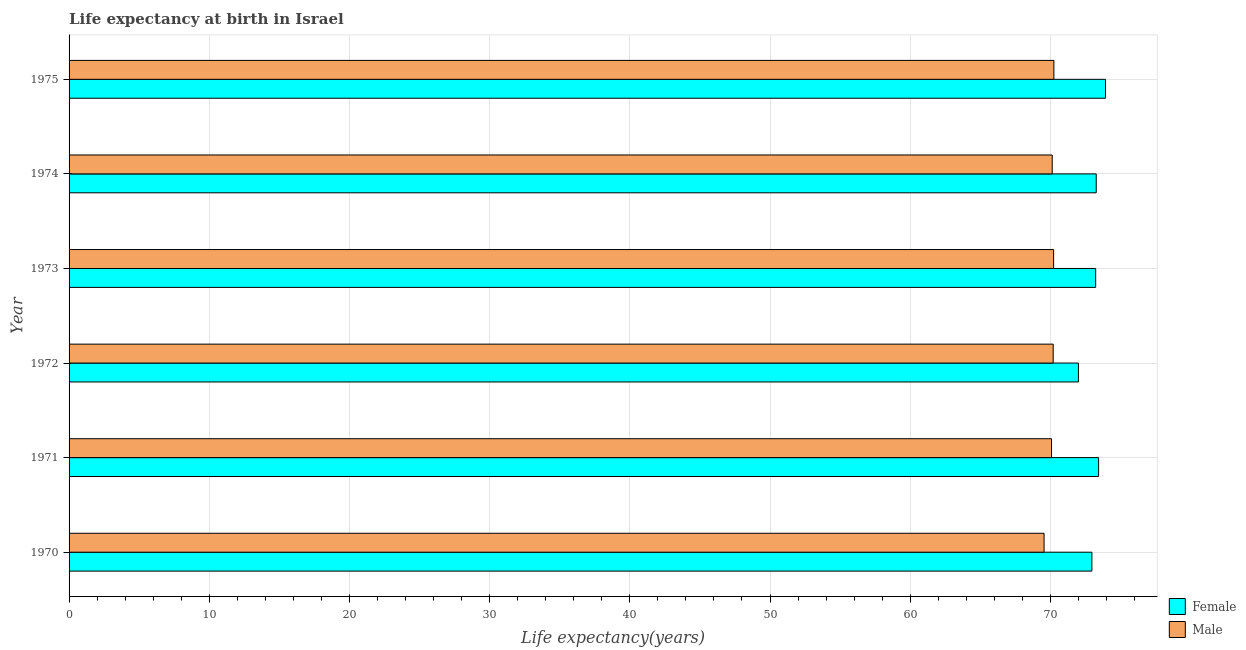How many different coloured bars are there?
Give a very brief answer. 2. Are the number of bars per tick equal to the number of legend labels?
Your answer should be very brief. Yes. Are the number of bars on each tick of the Y-axis equal?
Your response must be concise. Yes. How many bars are there on the 6th tick from the top?
Provide a succinct answer. 2. How many bars are there on the 1st tick from the bottom?
Keep it short and to the point. 2. What is the label of the 3rd group of bars from the top?
Your answer should be compact. 1973. In how many cases, is the number of bars for a given year not equal to the number of legend labels?
Offer a very short reply. 0. What is the life expectancy(male) in 1974?
Your answer should be compact. 70.13. Across all years, what is the maximum life expectancy(male)?
Provide a succinct answer. 70.25. In which year was the life expectancy(male) maximum?
Your answer should be compact. 1975. In which year was the life expectancy(male) minimum?
Your answer should be compact. 1970. What is the total life expectancy(female) in the graph?
Provide a short and direct response. 438.83. What is the difference between the life expectancy(male) in 1970 and that in 1973?
Ensure brevity in your answer.  -0.68. What is the difference between the life expectancy(male) in 1971 and the life expectancy(female) in 1970?
Your response must be concise. -2.88. What is the average life expectancy(male) per year?
Ensure brevity in your answer.  70.07. Is the difference between the life expectancy(male) in 1970 and 1973 greater than the difference between the life expectancy(female) in 1970 and 1973?
Make the answer very short. No. What is the difference between the highest and the second highest life expectancy(female)?
Ensure brevity in your answer.  0.49. What is the difference between the highest and the lowest life expectancy(female)?
Provide a succinct answer. 1.93. What does the 2nd bar from the top in 1972 represents?
Your answer should be compact. Female. What does the 2nd bar from the bottom in 1973 represents?
Make the answer very short. Male. Are all the bars in the graph horizontal?
Your answer should be very brief. Yes. How many years are there in the graph?
Provide a short and direct response. 6. What is the difference between two consecutive major ticks on the X-axis?
Offer a very short reply. 10. Are the values on the major ticks of X-axis written in scientific E-notation?
Offer a terse response. No. Does the graph contain any zero values?
Make the answer very short. No. Does the graph contain grids?
Keep it short and to the point. Yes. Where does the legend appear in the graph?
Ensure brevity in your answer.  Bottom right. How many legend labels are there?
Your answer should be compact. 2. How are the legend labels stacked?
Keep it short and to the point. Vertical. What is the title of the graph?
Provide a succinct answer. Life expectancy at birth in Israel. Does "Health Care" appear as one of the legend labels in the graph?
Give a very brief answer. No. What is the label or title of the X-axis?
Provide a succinct answer. Life expectancy(years). What is the label or title of the Y-axis?
Provide a succinct answer. Year. What is the Life expectancy(years) of Female in 1970?
Your answer should be very brief. 72.96. What is the Life expectancy(years) of Male in 1970?
Provide a succinct answer. 69.55. What is the Life expectancy(years) in Female in 1971?
Make the answer very short. 73.44. What is the Life expectancy(years) in Male in 1971?
Provide a short and direct response. 70.08. What is the Life expectancy(years) of Female in 1972?
Provide a succinct answer. 72. What is the Life expectancy(years) in Male in 1972?
Provide a succinct answer. 70.2. What is the Life expectancy(years) in Female in 1973?
Offer a very short reply. 73.23. What is the Life expectancy(years) in Male in 1973?
Provide a short and direct response. 70.23. What is the Life expectancy(years) of Female in 1974?
Keep it short and to the point. 73.27. What is the Life expectancy(years) of Male in 1974?
Your answer should be compact. 70.13. What is the Life expectancy(years) in Female in 1975?
Make the answer very short. 73.93. What is the Life expectancy(years) in Male in 1975?
Give a very brief answer. 70.25. Across all years, what is the maximum Life expectancy(years) of Female?
Offer a very short reply. 73.93. Across all years, what is the maximum Life expectancy(years) of Male?
Ensure brevity in your answer.  70.25. Across all years, what is the minimum Life expectancy(years) in Male?
Make the answer very short. 69.55. What is the total Life expectancy(years) in Female in the graph?
Provide a succinct answer. 438.83. What is the total Life expectancy(years) in Male in the graph?
Make the answer very short. 420.44. What is the difference between the Life expectancy(years) of Female in 1970 and that in 1971?
Offer a very short reply. -0.48. What is the difference between the Life expectancy(years) in Male in 1970 and that in 1971?
Offer a very short reply. -0.53. What is the difference between the Life expectancy(years) of Male in 1970 and that in 1972?
Make the answer very short. -0.65. What is the difference between the Life expectancy(years) of Female in 1970 and that in 1973?
Your answer should be very brief. -0.27. What is the difference between the Life expectancy(years) in Male in 1970 and that in 1973?
Provide a short and direct response. -0.68. What is the difference between the Life expectancy(years) in Female in 1970 and that in 1974?
Ensure brevity in your answer.  -0.31. What is the difference between the Life expectancy(years) in Male in 1970 and that in 1974?
Offer a terse response. -0.58. What is the difference between the Life expectancy(years) in Female in 1970 and that in 1975?
Give a very brief answer. -0.97. What is the difference between the Life expectancy(years) of Female in 1971 and that in 1972?
Make the answer very short. 1.44. What is the difference between the Life expectancy(years) of Male in 1971 and that in 1972?
Offer a terse response. -0.12. What is the difference between the Life expectancy(years) of Female in 1971 and that in 1973?
Your response must be concise. 0.21. What is the difference between the Life expectancy(years) of Female in 1971 and that in 1974?
Ensure brevity in your answer.  0.17. What is the difference between the Life expectancy(years) of Female in 1971 and that in 1975?
Your response must be concise. -0.49. What is the difference between the Life expectancy(years) in Male in 1971 and that in 1975?
Ensure brevity in your answer.  -0.17. What is the difference between the Life expectancy(years) of Female in 1972 and that in 1973?
Your answer should be very brief. -1.23. What is the difference between the Life expectancy(years) in Male in 1972 and that in 1973?
Your answer should be compact. -0.03. What is the difference between the Life expectancy(years) of Female in 1972 and that in 1974?
Offer a terse response. -1.27. What is the difference between the Life expectancy(years) of Male in 1972 and that in 1974?
Offer a terse response. 0.07. What is the difference between the Life expectancy(years) in Female in 1972 and that in 1975?
Your response must be concise. -1.93. What is the difference between the Life expectancy(years) in Male in 1972 and that in 1975?
Keep it short and to the point. -0.05. What is the difference between the Life expectancy(years) of Female in 1973 and that in 1974?
Offer a very short reply. -0.04. What is the difference between the Life expectancy(years) of Male in 1973 and that in 1974?
Ensure brevity in your answer.  0.1. What is the difference between the Life expectancy(years) in Female in 1973 and that in 1975?
Your response must be concise. -0.7. What is the difference between the Life expectancy(years) in Male in 1973 and that in 1975?
Provide a short and direct response. -0.02. What is the difference between the Life expectancy(years) in Female in 1974 and that in 1975?
Ensure brevity in your answer.  -0.66. What is the difference between the Life expectancy(years) of Male in 1974 and that in 1975?
Your answer should be compact. -0.12. What is the difference between the Life expectancy(years) of Female in 1970 and the Life expectancy(years) of Male in 1971?
Your response must be concise. 2.88. What is the difference between the Life expectancy(years) in Female in 1970 and the Life expectancy(years) in Male in 1972?
Offer a terse response. 2.76. What is the difference between the Life expectancy(years) in Female in 1970 and the Life expectancy(years) in Male in 1973?
Make the answer very short. 2.73. What is the difference between the Life expectancy(years) of Female in 1970 and the Life expectancy(years) of Male in 1974?
Your answer should be compact. 2.83. What is the difference between the Life expectancy(years) of Female in 1970 and the Life expectancy(years) of Male in 1975?
Provide a short and direct response. 2.71. What is the difference between the Life expectancy(years) of Female in 1971 and the Life expectancy(years) of Male in 1972?
Provide a short and direct response. 3.24. What is the difference between the Life expectancy(years) of Female in 1971 and the Life expectancy(years) of Male in 1973?
Your response must be concise. 3.21. What is the difference between the Life expectancy(years) in Female in 1971 and the Life expectancy(years) in Male in 1974?
Your answer should be compact. 3.31. What is the difference between the Life expectancy(years) of Female in 1971 and the Life expectancy(years) of Male in 1975?
Offer a very short reply. 3.19. What is the difference between the Life expectancy(years) in Female in 1972 and the Life expectancy(years) in Male in 1973?
Your answer should be very brief. 1.77. What is the difference between the Life expectancy(years) in Female in 1972 and the Life expectancy(years) in Male in 1974?
Ensure brevity in your answer.  1.87. What is the difference between the Life expectancy(years) in Female in 1972 and the Life expectancy(years) in Male in 1975?
Your response must be concise. 1.75. What is the difference between the Life expectancy(years) of Female in 1973 and the Life expectancy(years) of Male in 1974?
Give a very brief answer. 3.1. What is the difference between the Life expectancy(years) in Female in 1973 and the Life expectancy(years) in Male in 1975?
Ensure brevity in your answer.  2.98. What is the difference between the Life expectancy(years) of Female in 1974 and the Life expectancy(years) of Male in 1975?
Your response must be concise. 3.02. What is the average Life expectancy(years) in Female per year?
Offer a terse response. 73.14. What is the average Life expectancy(years) in Male per year?
Keep it short and to the point. 70.07. In the year 1970, what is the difference between the Life expectancy(years) of Female and Life expectancy(years) of Male?
Give a very brief answer. 3.41. In the year 1971, what is the difference between the Life expectancy(years) of Female and Life expectancy(years) of Male?
Offer a very short reply. 3.36. In the year 1972, what is the difference between the Life expectancy(years) of Female and Life expectancy(years) of Male?
Offer a terse response. 1.8. In the year 1974, what is the difference between the Life expectancy(years) in Female and Life expectancy(years) in Male?
Provide a short and direct response. 3.14. In the year 1975, what is the difference between the Life expectancy(years) of Female and Life expectancy(years) of Male?
Your response must be concise. 3.68. What is the ratio of the Life expectancy(years) of Male in 1970 to that in 1971?
Your response must be concise. 0.99. What is the ratio of the Life expectancy(years) in Female in 1970 to that in 1972?
Offer a terse response. 1.01. What is the ratio of the Life expectancy(years) in Female in 1970 to that in 1973?
Offer a terse response. 1. What is the ratio of the Life expectancy(years) in Male in 1970 to that in 1973?
Ensure brevity in your answer.  0.99. What is the ratio of the Life expectancy(years) of Male in 1970 to that in 1974?
Make the answer very short. 0.99. What is the ratio of the Life expectancy(years) in Female in 1970 to that in 1975?
Make the answer very short. 0.99. What is the ratio of the Life expectancy(years) in Male in 1970 to that in 1975?
Your response must be concise. 0.99. What is the ratio of the Life expectancy(years) of Male in 1971 to that in 1973?
Keep it short and to the point. 1. What is the ratio of the Life expectancy(years) in Male in 1971 to that in 1974?
Provide a short and direct response. 1. What is the ratio of the Life expectancy(years) of Female in 1971 to that in 1975?
Your answer should be compact. 0.99. What is the ratio of the Life expectancy(years) of Male in 1971 to that in 1975?
Ensure brevity in your answer.  1. What is the ratio of the Life expectancy(years) of Female in 1972 to that in 1973?
Offer a terse response. 0.98. What is the ratio of the Life expectancy(years) in Female in 1972 to that in 1974?
Your response must be concise. 0.98. What is the ratio of the Life expectancy(years) in Male in 1972 to that in 1974?
Keep it short and to the point. 1. What is the ratio of the Life expectancy(years) of Female in 1972 to that in 1975?
Your answer should be very brief. 0.97. What is the ratio of the Life expectancy(years) of Female in 1973 to that in 1974?
Your answer should be compact. 1. What is the ratio of the Life expectancy(years) of Male in 1973 to that in 1974?
Offer a terse response. 1. What is the ratio of the Life expectancy(years) in Male in 1973 to that in 1975?
Offer a terse response. 1. What is the ratio of the Life expectancy(years) of Female in 1974 to that in 1975?
Keep it short and to the point. 0.99. What is the ratio of the Life expectancy(years) of Male in 1974 to that in 1975?
Offer a terse response. 1. What is the difference between the highest and the second highest Life expectancy(years) of Female?
Provide a short and direct response. 0.49. What is the difference between the highest and the second highest Life expectancy(years) of Male?
Give a very brief answer. 0.02. What is the difference between the highest and the lowest Life expectancy(years) of Female?
Ensure brevity in your answer.  1.93. What is the difference between the highest and the lowest Life expectancy(years) in Male?
Make the answer very short. 0.7. 